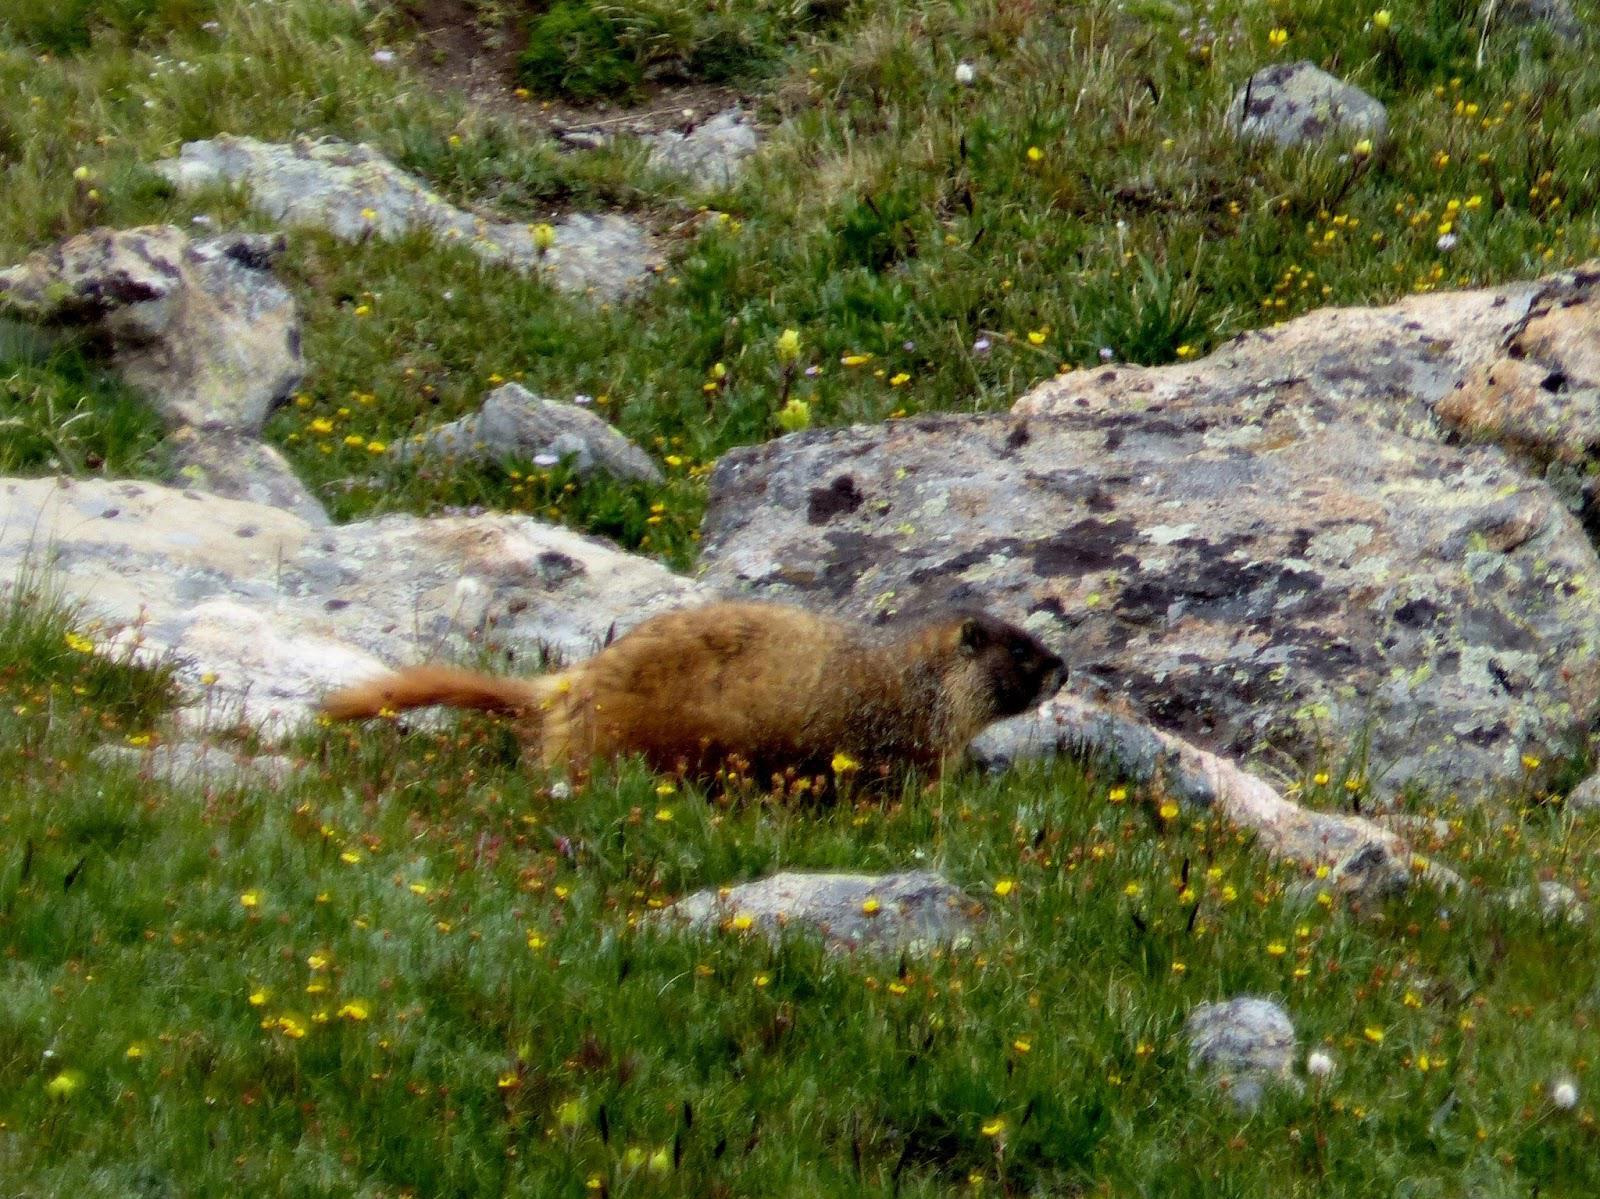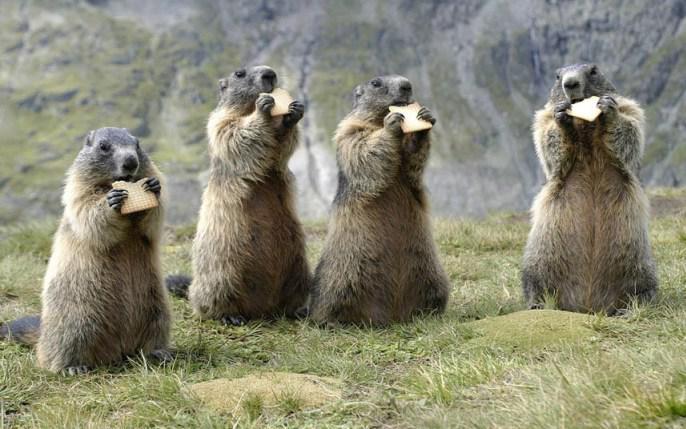The first image is the image on the left, the second image is the image on the right. Examine the images to the left and right. Is the description "There are at least two animals in the image on the right." accurate? Answer yes or no. Yes. The first image is the image on the left, the second image is the image on the right. For the images displayed, is the sentence "There is only one animal is eating." factually correct? Answer yes or no. No. 